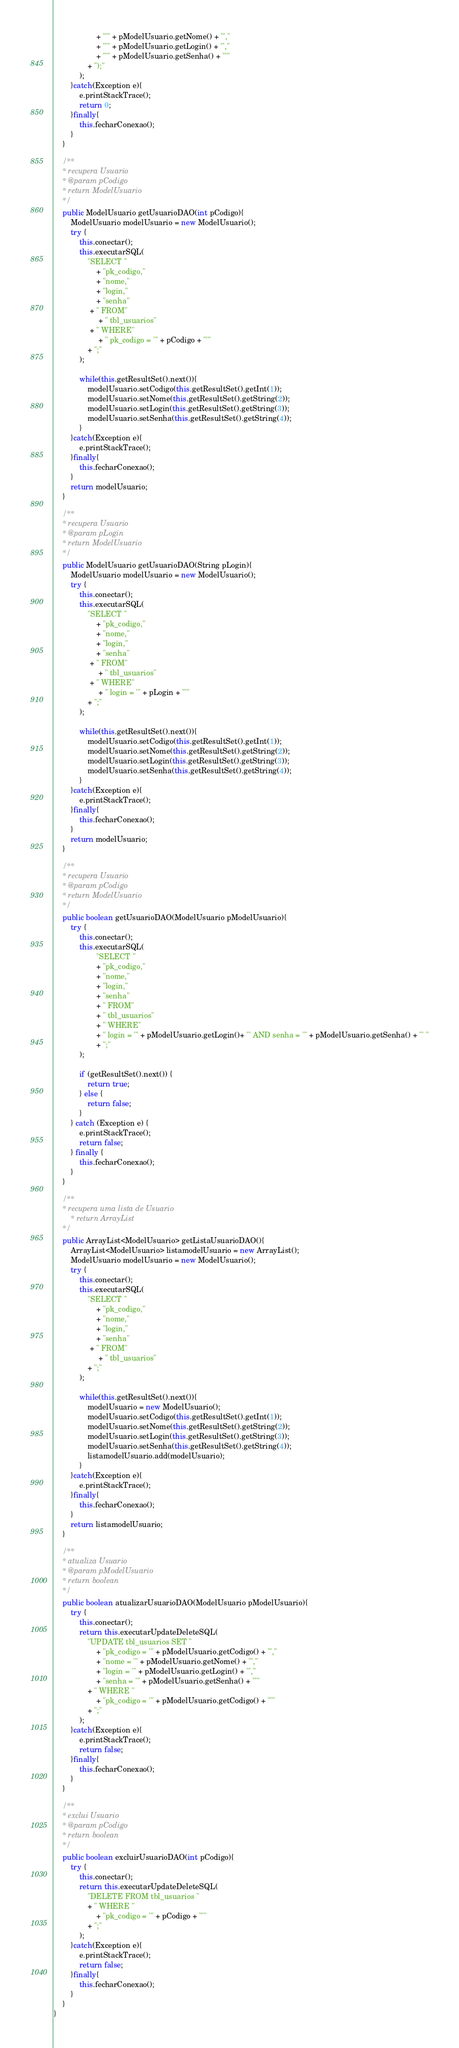Convert code to text. <code><loc_0><loc_0><loc_500><loc_500><_Java_>                    + "'" + pModelUsuario.getNome() + "',"
                    + "'" + pModelUsuario.getLogin() + "',"
                    + "'" + pModelUsuario.getSenha() + "'"
                + ");"
            );
        }catch(Exception e){
            e.printStackTrace();
            return 0;
        }finally{
            this.fecharConexao();
        }
    }

    /**
    * recupera Usuario
    * @param pCodigo
    * return ModelUsuario
    */
    public ModelUsuario getUsuarioDAO(int pCodigo){
        ModelUsuario modelUsuario = new ModelUsuario();
        try {
            this.conectar();
            this.executarSQL(
                "SELECT "
                    + "pk_codigo,"
                    + "nome,"
                    + "login,"
                    + "senha"
                 + " FROM"
                     + " tbl_usuarios"
                 + " WHERE"
                     + " pk_codigo = '" + pCodigo + "'"
                + ";"
            );

            while(this.getResultSet().next()){
                modelUsuario.setCodigo(this.getResultSet().getInt(1));
                modelUsuario.setNome(this.getResultSet().getString(2));
                modelUsuario.setLogin(this.getResultSet().getString(3));
                modelUsuario.setSenha(this.getResultSet().getString(4));
            }
        }catch(Exception e){
            e.printStackTrace();
        }finally{
            this.fecharConexao();
        }
        return modelUsuario;
    }

    /**
    * recupera Usuario
    * @param pLogin
    * return ModelUsuario
    */
    public ModelUsuario getUsuarioDAO(String pLogin){
        ModelUsuario modelUsuario = new ModelUsuario();
        try {
            this.conectar();
            this.executarSQL(
                "SELECT "
                    + "pk_codigo,"
                    + "nome,"
                    + "login,"
                    + "senha"
                 + " FROM"
                     + " tbl_usuarios"
                 + " WHERE"
                     + " login = '" + pLogin + "'"
                + ";"
            );

            while(this.getResultSet().next()){
                modelUsuario.setCodigo(this.getResultSet().getInt(1));
                modelUsuario.setNome(this.getResultSet().getString(2));
                modelUsuario.setLogin(this.getResultSet().getString(3));
                modelUsuario.setSenha(this.getResultSet().getString(4));
            }
        }catch(Exception e){
            e.printStackTrace();
        }finally{
            this.fecharConexao();
        }
        return modelUsuario;
    }
    
    /**
    * recupera Usuario
    * @param pCodigo
    * return ModelUsuario
    */
    public boolean getUsuarioDAO(ModelUsuario pModelUsuario){       
        try {
            this.conectar();
            this.executarSQL(
                    "SELECT "
                    + "pk_codigo,"
                    + "nome,"
                    + "login,"
                    + "senha"
                    + " FROM"
                    + " tbl_usuarios"
                    + " WHERE"
                    + " login = '" + pModelUsuario.getLogin()+ "' AND senha = '" + pModelUsuario.getSenha() + "' "
                    + ";"
            );

            if (getResultSet().next()) {
                return true;
            } else {
                return false;
            }
        } catch (Exception e) {
            e.printStackTrace();
            return false;
        } finally {
            this.fecharConexao();
        }      
    }
    
    /**
    * recupera uma lista de Usuario
        * return ArrayList
    */
    public ArrayList<ModelUsuario> getListaUsuarioDAO(){
        ArrayList<ModelUsuario> listamodelUsuario = new ArrayList();
        ModelUsuario modelUsuario = new ModelUsuario();
        try {
            this.conectar();
            this.executarSQL(
                "SELECT "
                    + "pk_codigo,"
                    + "nome,"
                    + "login,"
                    + "senha"
                 + " FROM"
                     + " tbl_usuarios"
                + ";"
            );

            while(this.getResultSet().next()){
                modelUsuario = new ModelUsuario();
                modelUsuario.setCodigo(this.getResultSet().getInt(1));
                modelUsuario.setNome(this.getResultSet().getString(2));
                modelUsuario.setLogin(this.getResultSet().getString(3));
                modelUsuario.setSenha(this.getResultSet().getString(4));
                listamodelUsuario.add(modelUsuario);
            }
        }catch(Exception e){
            e.printStackTrace();
        }finally{
            this.fecharConexao();
        }
        return listamodelUsuario;
    }

    /**
    * atualiza Usuario
    * @param pModelUsuario
    * return boolean
    */
    public boolean atualizarUsuarioDAO(ModelUsuario pModelUsuario){
        try {
            this.conectar();
            return this.executarUpdateDeleteSQL(
                "UPDATE tbl_usuarios SET "
                    + "pk_codigo = '" + pModelUsuario.getCodigo() + "',"
                    + "nome = '" + pModelUsuario.getNome() + "',"
                    + "login = '" + pModelUsuario.getLogin() + "',"
                    + "senha = '" + pModelUsuario.getSenha() + "'"
                + " WHERE "
                    + "pk_codigo = '" + pModelUsuario.getCodigo() + "'"
                + ";"
            );
        }catch(Exception e){
            e.printStackTrace();
            return false;
        }finally{
            this.fecharConexao();
        }
    }

    /**
    * exclui Usuario
    * @param pCodigo
    * return boolean
    */
    public boolean excluirUsuarioDAO(int pCodigo){
        try {
            this.conectar();
            return this.executarUpdateDeleteSQL(
                "DELETE FROM tbl_usuarios "
                + " WHERE "
                    + "pk_codigo = '" + pCodigo + "'"
                + ";"
            );
        }catch(Exception e){
            e.printStackTrace();
            return false;
        }finally{
            this.fecharConexao();
        }
    }
}</code> 